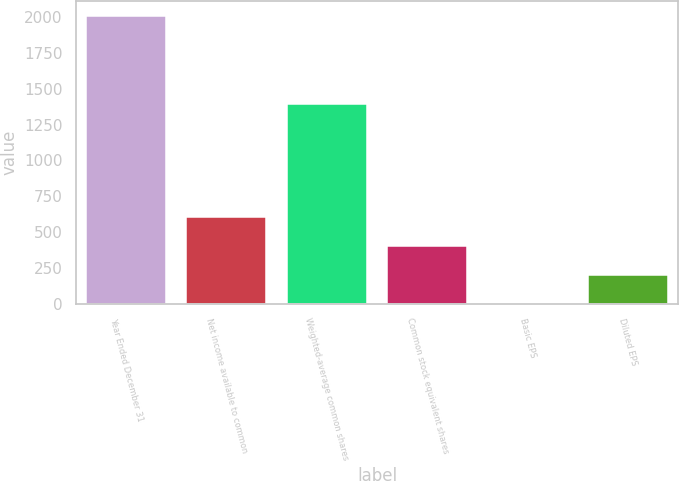Convert chart to OTSL. <chart><loc_0><loc_0><loc_500><loc_500><bar_chart><fcel>Year Ended December 31<fcel>Net income available to common<fcel>Weighted-average common shares<fcel>Common stock equivalent shares<fcel>Basic EPS<fcel>Diluted EPS<nl><fcel>2010<fcel>603.26<fcel>1391.96<fcel>402.3<fcel>0.38<fcel>201.34<nl></chart> 